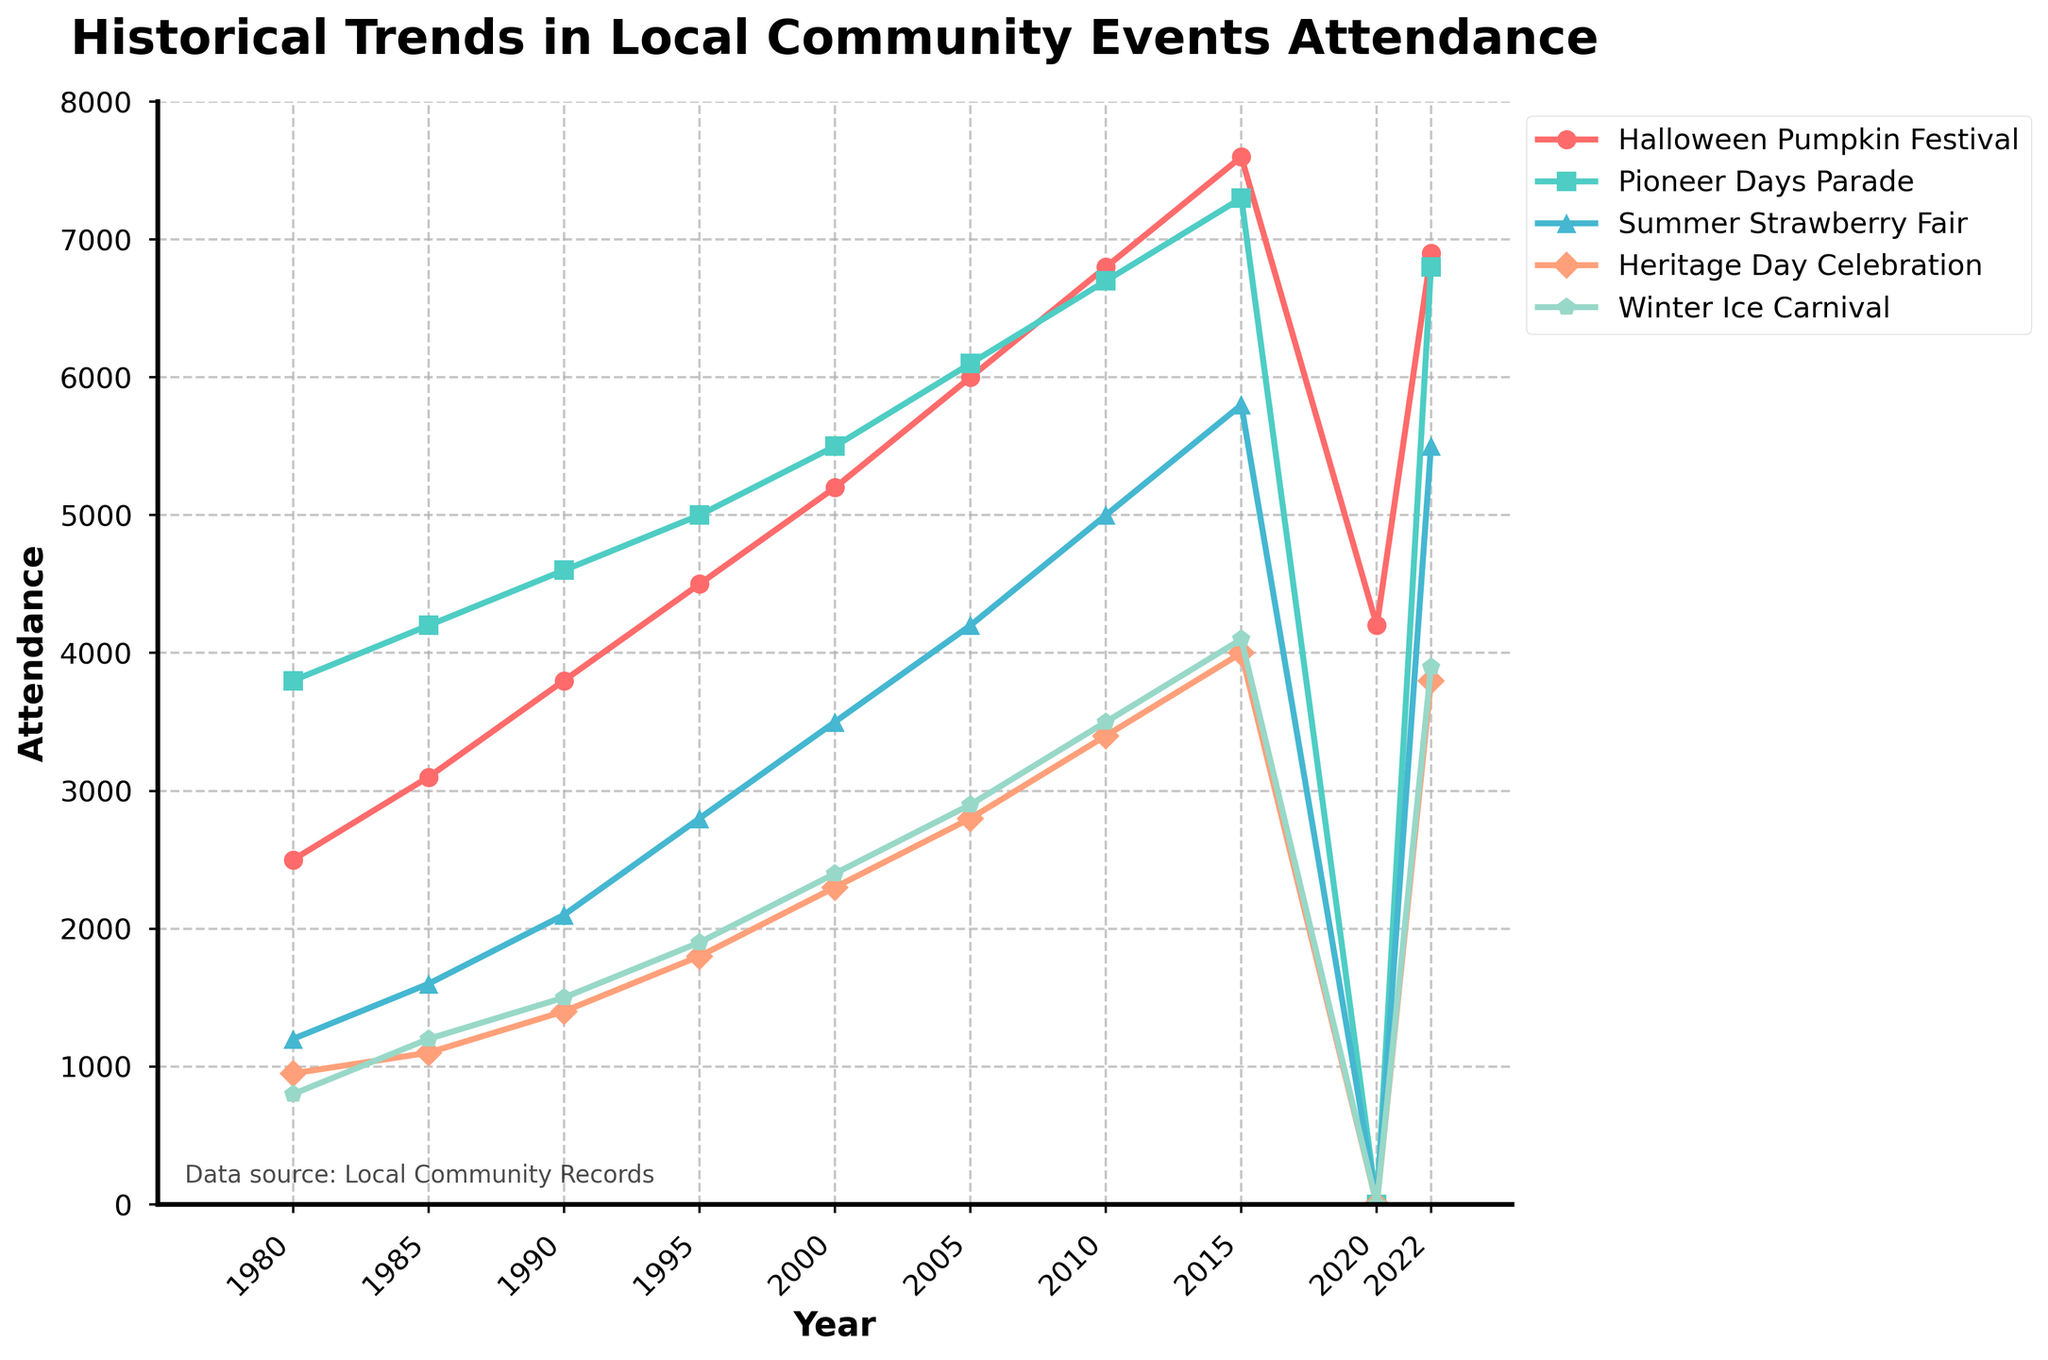What is the overall attendance trend for the Halloween Pumpkin Festival from 1980 to 2022? Look at the line representing the Halloween Pumpkin Festival from 1980 to 2022. The attendance generally increases over the years, with a sharp drop in 2020 but then recovering strongly by 2022.
Answer: Increasing trend with a drop in 2020 Which event had the lowest attendance in 1980? Compare the attendance values for all events in 1980. The Winter Ice Carnival had the lowest attendance, with 800 attendees.
Answer: Winter Ice Carnival How did the attendance for the Winter Ice Carnival change from 1980 to 2015? Compare the attendance values for the Winter Ice Carnival in 1980 and 2015. The attendance increased from 800 to 4100 over these years.
Answer: Increased Which year had the highest combined attendance for all five events? Sum the attendance for all five events for each year and compare. The year with the highest combined attendance is 2015.
Answer: 2015 Between 2000 and 2010, which event showed the greatest increase in attendance? Compare the attendance differences between 2000 and 2010 for all events. The Halloween Pumpkin Festival showed the greatest increase, from 5200 to 6800.
Answer: Halloween Pumpkin Festival What happened to the Pioneer Days Parade in 2020? Observe the attendance for the Pioneer Days Parade in 2020. It is marked as zero, indicating the event did not occur.
Answer: The event did not occur Which event had the most consistent growth in attendance throughout the years? Look at the trends for all events from 1980 to 2022. The Summer Strawberry Fair and the Halloween Pumpkin Festival show consistent growth, but the Halloween Pumpkin Festival has a clearer upward trend with fewer fluctuations.
Answer: Halloween Pumpkin Festival Compare the attendance between the Pioneer Days Parade and the Heritage Day Celebration in 2022. Look at the attendance values for both events in 2022. The Pioneer Days Parade had 6800 attendees, while the Heritage Day Celebration had 3800 attendees.
Answer: Pioneer Days Parade had higher attendance What is the visual trend noticed for all events in the year 2020? Observe the attendance levels for all events in 2020. All events except the Halloween Pumpkin Festival have zero attendance, indicating a significant drop or cancellation in that year.
Answer: Most events had zero attendance Calculate the average attendance of the Summer Strawberry Fair across all recorded years. Sum the attendance values for the Summer Strawberry Fair across all years and divide by the number of years. The sum is 1200 + 1600 + 2100 + 2800 + 3500 + 4200 + 5000 + 5800 + 0 + 5500 = 31700. Dividing by 10 gives an average of 3170.
Answer: 3170 